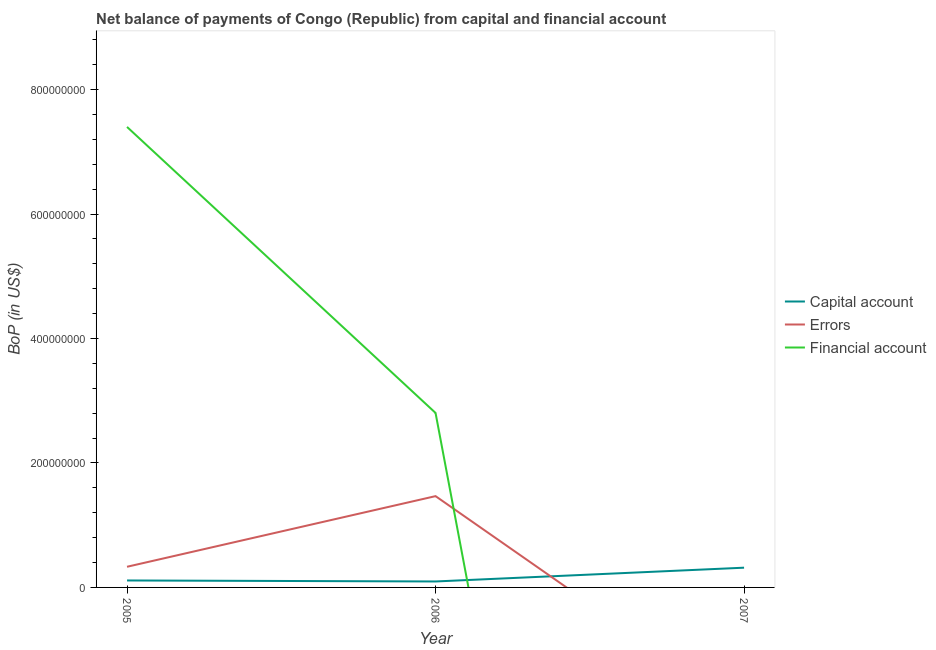How many different coloured lines are there?
Make the answer very short. 3. Does the line corresponding to amount of errors intersect with the line corresponding to amount of financial account?
Keep it short and to the point. Yes. What is the amount of errors in 2005?
Ensure brevity in your answer.  3.32e+07. Across all years, what is the maximum amount of net capital account?
Provide a succinct answer. 3.17e+07. Across all years, what is the minimum amount of errors?
Give a very brief answer. 0. What is the total amount of financial account in the graph?
Offer a terse response. 1.02e+09. What is the difference between the amount of errors in 2005 and that in 2006?
Give a very brief answer. -1.14e+08. What is the difference between the amount of net capital account in 2007 and the amount of financial account in 2006?
Offer a very short reply. -2.49e+08. What is the average amount of errors per year?
Your answer should be compact. 6.00e+07. In the year 2006, what is the difference between the amount of errors and amount of financial account?
Offer a terse response. -1.34e+08. In how many years, is the amount of financial account greater than 680000000 US$?
Your response must be concise. 1. What is the ratio of the amount of net capital account in 2005 to that in 2007?
Make the answer very short. 0.35. Is the amount of errors in 2005 less than that in 2006?
Your answer should be compact. Yes. What is the difference between the highest and the second highest amount of net capital account?
Give a very brief answer. 2.05e+07. What is the difference between the highest and the lowest amount of net capital account?
Offer a very short reply. 2.22e+07. In how many years, is the amount of net capital account greater than the average amount of net capital account taken over all years?
Provide a short and direct response. 1. Is the sum of the amount of errors in 2005 and 2006 greater than the maximum amount of financial account across all years?
Your answer should be compact. No. Is it the case that in every year, the sum of the amount of net capital account and amount of errors is greater than the amount of financial account?
Make the answer very short. No. Does the amount of financial account monotonically increase over the years?
Offer a terse response. No. Is the amount of financial account strictly greater than the amount of errors over the years?
Ensure brevity in your answer.  No. Is the amount of net capital account strictly less than the amount of financial account over the years?
Offer a very short reply. No. How many years are there in the graph?
Offer a very short reply. 3. What is the difference between two consecutive major ticks on the Y-axis?
Offer a very short reply. 2.00e+08. Does the graph contain grids?
Offer a terse response. No. How many legend labels are there?
Offer a very short reply. 3. How are the legend labels stacked?
Offer a very short reply. Vertical. What is the title of the graph?
Ensure brevity in your answer.  Net balance of payments of Congo (Republic) from capital and financial account. Does "Neonatal" appear as one of the legend labels in the graph?
Your answer should be compact. No. What is the label or title of the X-axis?
Offer a terse response. Year. What is the label or title of the Y-axis?
Offer a terse response. BoP (in US$). What is the BoP (in US$) of Capital account in 2005?
Offer a terse response. 1.12e+07. What is the BoP (in US$) of Errors in 2005?
Provide a short and direct response. 3.32e+07. What is the BoP (in US$) of Financial account in 2005?
Provide a short and direct response. 7.40e+08. What is the BoP (in US$) of Capital account in 2006?
Offer a very short reply. 9.56e+06. What is the BoP (in US$) of Errors in 2006?
Your response must be concise. 1.47e+08. What is the BoP (in US$) in Financial account in 2006?
Provide a succinct answer. 2.80e+08. What is the BoP (in US$) in Capital account in 2007?
Your answer should be very brief. 3.17e+07. What is the BoP (in US$) of Financial account in 2007?
Your response must be concise. 0. Across all years, what is the maximum BoP (in US$) of Capital account?
Give a very brief answer. 3.17e+07. Across all years, what is the maximum BoP (in US$) of Errors?
Your response must be concise. 1.47e+08. Across all years, what is the maximum BoP (in US$) in Financial account?
Your response must be concise. 7.40e+08. Across all years, what is the minimum BoP (in US$) in Capital account?
Ensure brevity in your answer.  9.56e+06. Across all years, what is the minimum BoP (in US$) of Errors?
Provide a succinct answer. 0. Across all years, what is the minimum BoP (in US$) of Financial account?
Your answer should be very brief. 0. What is the total BoP (in US$) in Capital account in the graph?
Make the answer very short. 5.25e+07. What is the total BoP (in US$) in Errors in the graph?
Give a very brief answer. 1.80e+08. What is the total BoP (in US$) of Financial account in the graph?
Make the answer very short. 1.02e+09. What is the difference between the BoP (in US$) in Capital account in 2005 and that in 2006?
Ensure brevity in your answer.  1.62e+06. What is the difference between the BoP (in US$) in Errors in 2005 and that in 2006?
Give a very brief answer. -1.14e+08. What is the difference between the BoP (in US$) in Financial account in 2005 and that in 2006?
Keep it short and to the point. 4.60e+08. What is the difference between the BoP (in US$) in Capital account in 2005 and that in 2007?
Make the answer very short. -2.05e+07. What is the difference between the BoP (in US$) in Capital account in 2006 and that in 2007?
Your answer should be compact. -2.22e+07. What is the difference between the BoP (in US$) of Capital account in 2005 and the BoP (in US$) of Errors in 2006?
Your answer should be very brief. -1.35e+08. What is the difference between the BoP (in US$) in Capital account in 2005 and the BoP (in US$) in Financial account in 2006?
Offer a very short reply. -2.69e+08. What is the difference between the BoP (in US$) in Errors in 2005 and the BoP (in US$) in Financial account in 2006?
Provide a short and direct response. -2.47e+08. What is the average BoP (in US$) of Capital account per year?
Your answer should be compact. 1.75e+07. What is the average BoP (in US$) in Errors per year?
Keep it short and to the point. 6.00e+07. What is the average BoP (in US$) in Financial account per year?
Your response must be concise. 3.40e+08. In the year 2005, what is the difference between the BoP (in US$) of Capital account and BoP (in US$) of Errors?
Provide a succinct answer. -2.20e+07. In the year 2005, what is the difference between the BoP (in US$) of Capital account and BoP (in US$) of Financial account?
Your response must be concise. -7.29e+08. In the year 2005, what is the difference between the BoP (in US$) of Errors and BoP (in US$) of Financial account?
Make the answer very short. -7.07e+08. In the year 2006, what is the difference between the BoP (in US$) of Capital account and BoP (in US$) of Errors?
Offer a terse response. -1.37e+08. In the year 2006, what is the difference between the BoP (in US$) of Capital account and BoP (in US$) of Financial account?
Make the answer very short. -2.71e+08. In the year 2006, what is the difference between the BoP (in US$) in Errors and BoP (in US$) in Financial account?
Provide a short and direct response. -1.34e+08. What is the ratio of the BoP (in US$) in Capital account in 2005 to that in 2006?
Ensure brevity in your answer.  1.17. What is the ratio of the BoP (in US$) in Errors in 2005 to that in 2006?
Offer a very short reply. 0.23. What is the ratio of the BoP (in US$) of Financial account in 2005 to that in 2006?
Give a very brief answer. 2.64. What is the ratio of the BoP (in US$) of Capital account in 2005 to that in 2007?
Ensure brevity in your answer.  0.35. What is the ratio of the BoP (in US$) of Capital account in 2006 to that in 2007?
Provide a short and direct response. 0.3. What is the difference between the highest and the second highest BoP (in US$) in Capital account?
Make the answer very short. 2.05e+07. What is the difference between the highest and the lowest BoP (in US$) of Capital account?
Your response must be concise. 2.22e+07. What is the difference between the highest and the lowest BoP (in US$) of Errors?
Provide a short and direct response. 1.47e+08. What is the difference between the highest and the lowest BoP (in US$) of Financial account?
Ensure brevity in your answer.  7.40e+08. 